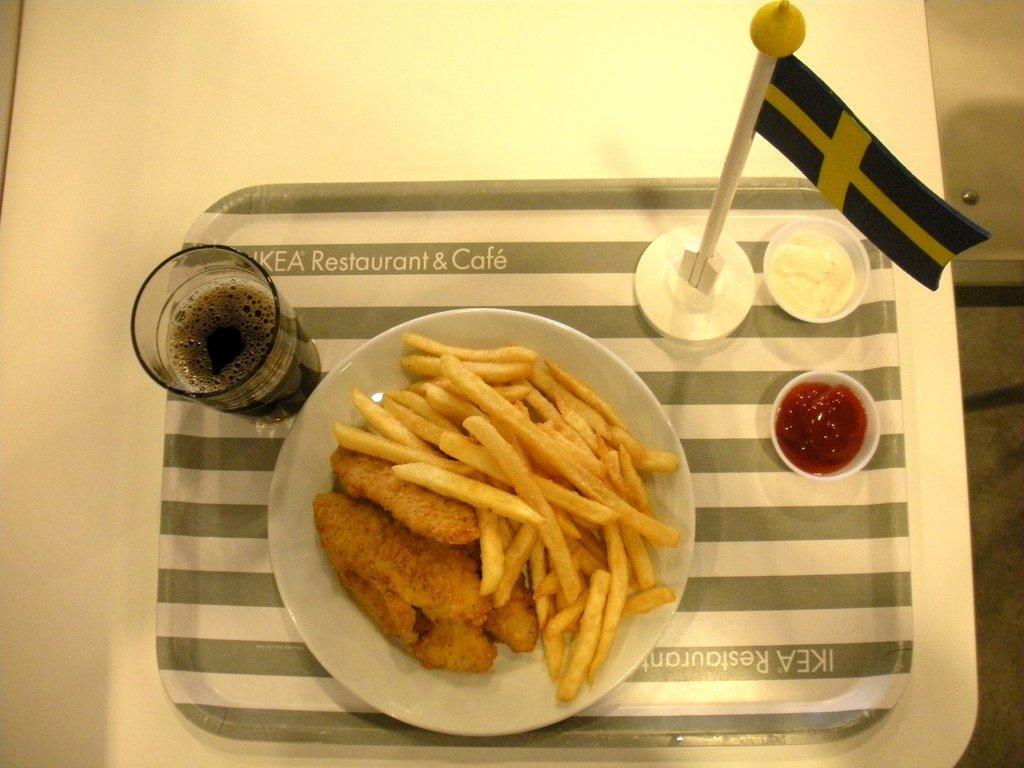Could you give a brief overview of what you see in this image? Here I can see a table on which a tray, plate, glass, flag, two bowls are placed. On the plate I can see some fries and some other food item. 